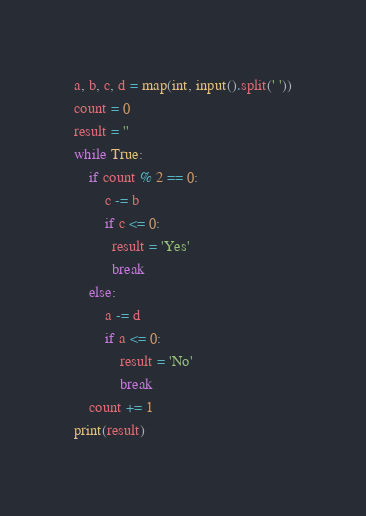Convert code to text. <code><loc_0><loc_0><loc_500><loc_500><_Python_>a, b, c, d = map(int, input().split(' '))
count = 0
result = ''
while True:
    if count % 2 == 0:
        c -= b
        if c <= 0:
          result = 'Yes'
          break  
    else:
        a -= d
        if a <= 0:
            result = 'No'
            break
    count += 1
print(result)</code> 